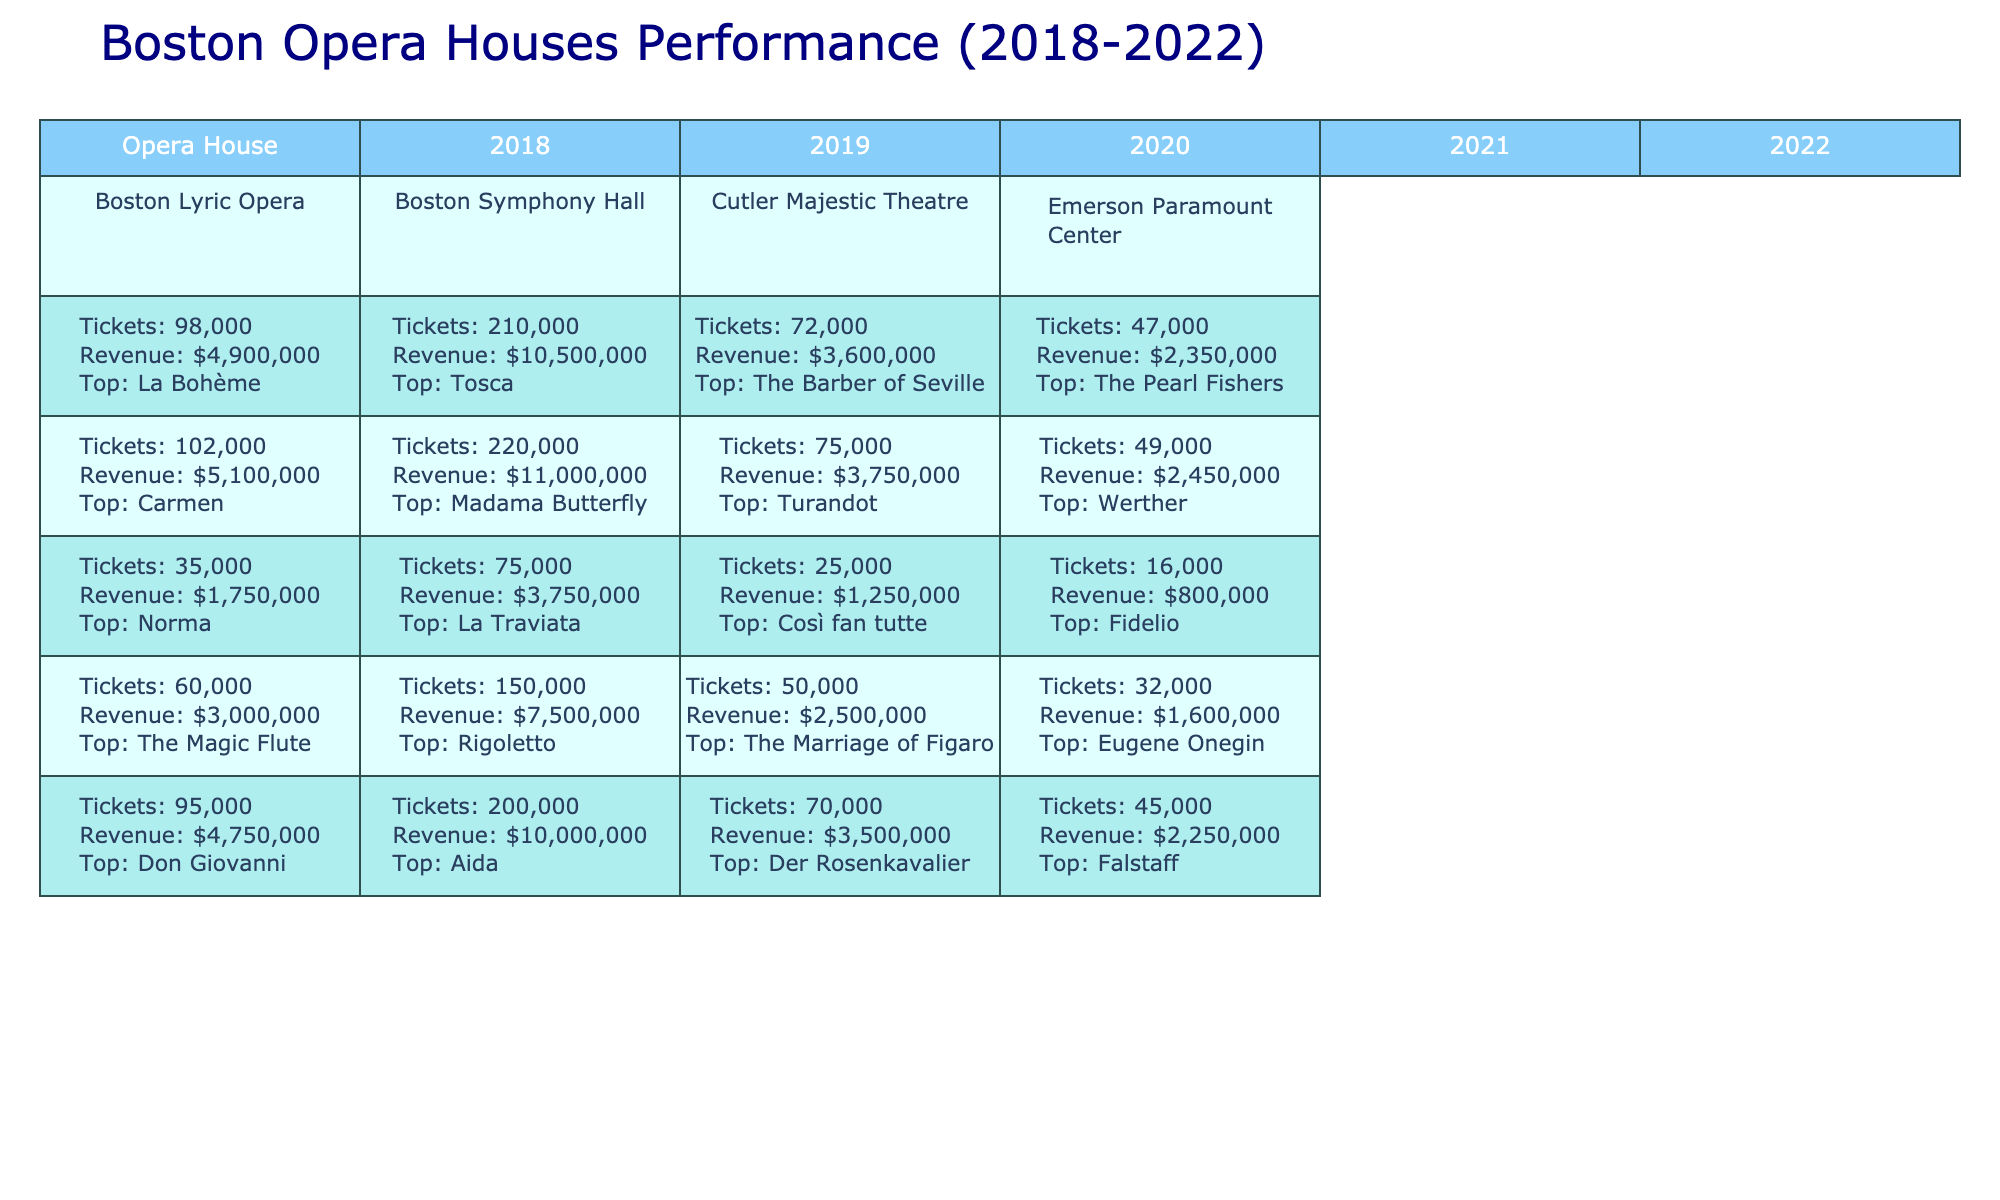What was the most popular production at the Boston Lyric Opera in 2020? Referring to the data for the Boston Lyric Opera in 2020, the most popular production was "Norma."
Answer: Norma Which opera house had the highest ticket sales in 2021? In 2021, the Boston Symphony Hall had the highest ticket sales of 150,000, compared to the other venues.
Answer: Boston Symphony Hall What was the total revenue generated by the Cutler Majestic Theatre in 2019 and 2020? For 2019, the revenue was $3,750,000, and for 2020, it was $1,250,000. Adding these gives $3,750,000 + $1,250,000 = $5,000,000.
Answer: $5,000,000 Was the ticket sales figure for Emerson Paramount Center in 2020 greater than those in 2018? The ticket sales for Emerson Paramount Center in 2020 were 16,000, which is less than the 47,000 tickets sold in 2018.
Answer: No What was the average ticket sales for the Boston Symphony Hall from 2018 to 2022? The ticket sales over these years are 210,000, 220,000, 75,000, 150,000, and 200,000. The sum of these figures is 855,000, and there are 5 years, so the average is 855,000/5 = 171,000.
Answer: 171,000 In which year did the Cutler Majestic Theatre experience the lowest ticket sales? Looking at the data for the Cutler Majestic Theatre, the lowest ticket sales were in 2020, with only 25,000 tickets sold.
Answer: 2020 How much revenue did the Boston Lyric Opera generate in total from 2018 to 2022? The revenues for each year are $4,900,000, $5,100,000, $1,750,000, $3,000,000, and $4,750,000. Adding these amounts gives a total revenue of $19,500,000.
Answer: $19,500,000 Which year saw the highest revenue for the Boston Symphony Hall? The highest revenue for the Boston Symphony Hall occurred in 2019 with $11,000,000.
Answer: 2019 How many more tickets were sold in 2022 compared to 2020 at the Boston Lyric Opera? In 2022, 95,000 tickets were sold, while in 2020, only 35,000 were sold. The difference is 95,000 - 35,000 = 60,000 tickets.
Answer: 60,000 Did the revenue for the Emerson Paramount Center in 2021 exceed that in 2020? In 2021, the Emerson Paramount Center generated $1,600,000, which is greater than the $800,000 in 2020.
Answer: Yes 